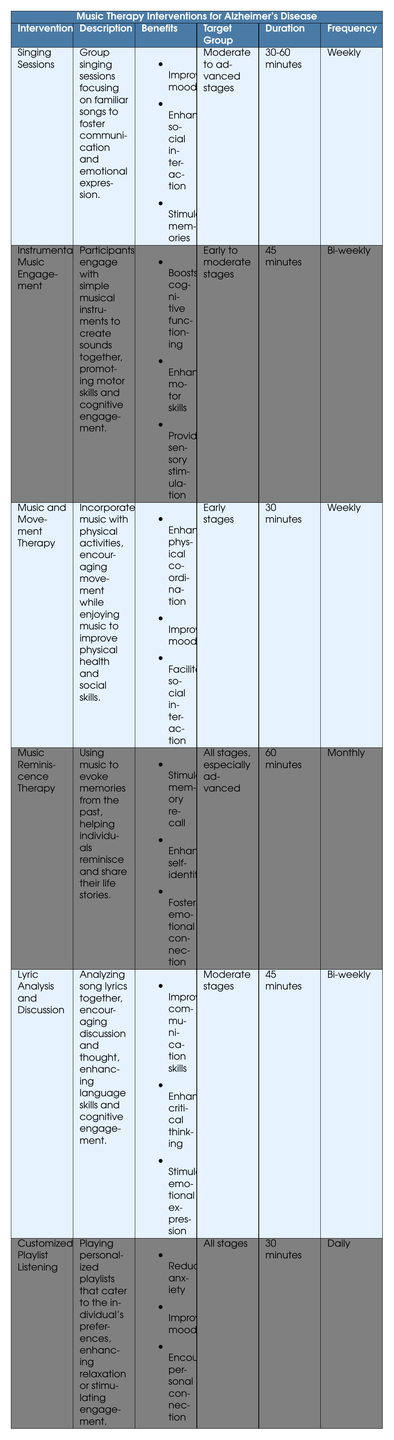What is the duration of the Music Reminiscence Therapy intervention? The duration for Music Reminiscence Therapy is explicitly stated in the table as 60 minutes.
Answer: 60 minutes How often are Singing Sessions held? According to the table, Singing Sessions are conducted weekly.
Answer: Weekly Which intervention has benefits related to both mood improvement and social interaction? By examining the benefits listed, Singing Sessions and Music and Movement Therapy both include improving mood and enhancing social interaction. Thus, these two interventions share those benefits.
Answer: Singing Sessions, Music and Movement Therapy Is the target group for Customized Playlist Listening limited only to individuals in advanced stages? The table indicates that the target group for Customized Playlist Listening is "All stages," so it is not limited to advanced stages.
Answer: No What is the difference in frequency between Music Reminiscence Therapy and Lyric Analysis and Discussion? Music Reminiscence Therapy is held monthly while Lyric Analysis and Discussion occurs bi-weekly. Therefore, the frequency difference is that Music Reminiscence Therapy is held less often than Lyric Analysis and Discussion.
Answer: Monthly vs. Bi-weekly Which intervention should be used primarily for individuals in early stages and focuses on physical health? The table lists Music and Movement Therapy as the intervention that encompasses both early-stage targeting and a focus on physical health through music and movement.
Answer: Music and Movement Therapy What are the benefits of Instrumental Music Engagement? The benefits listed for Instrumental Music Engagement include boosting cognitive functioning, enhancing motor skills, and providing sensory stimulation.
Answer: Boosts cognitive functioning, enhances motor skills, provides sensory stimulation If a facility were to implement all interventions listed in the table, how many different durations would be covered? The unique durations across all interventions include 30 minutes, 45 minutes, 60 minutes, and 30-60 minutes. In total, there are four different durations.
Answer: Four different durations Which intervention is designed for all stages and focuses on personal preferences? According to the table, Customized Playlist Listening is specifically designed to cater to all stages and emphasizes playing personalized playlists based on individual preferences.
Answer: Customized Playlist Listening 